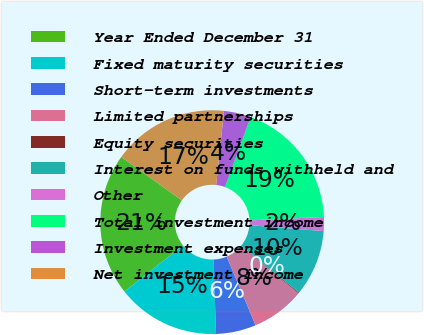Convert chart. <chart><loc_0><loc_0><loc_500><loc_500><pie_chart><fcel>Year Ended December 31<fcel>Fixed maturity securities<fcel>Short-term investments<fcel>Limited partnerships<fcel>Equity securities<fcel>Interest on funds withheld and<fcel>Other<fcel>Total investment income<fcel>Investment expenses<fcel>Net investment income<nl><fcel>20.56%<fcel>14.9%<fcel>5.79%<fcel>7.68%<fcel>0.13%<fcel>9.57%<fcel>2.02%<fcel>18.67%<fcel>3.9%<fcel>16.78%<nl></chart> 